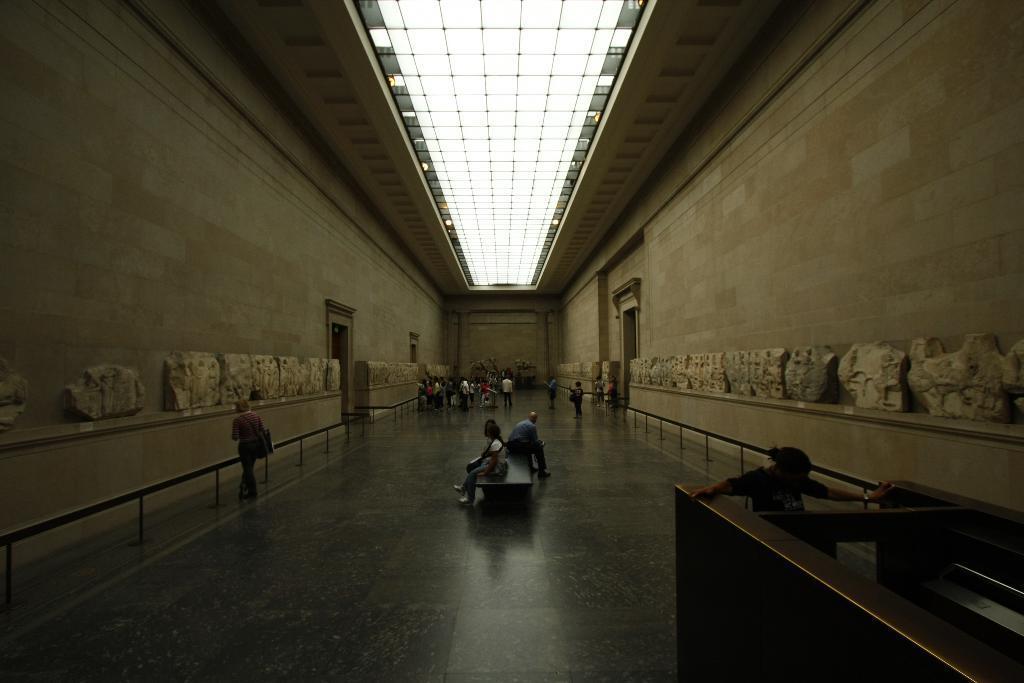How would you summarize this image in a sentence or two? In this image we can see people and few of them are sitting on a platform. Here we can see railing, walls, ceiling, lights, floor, and an object. 